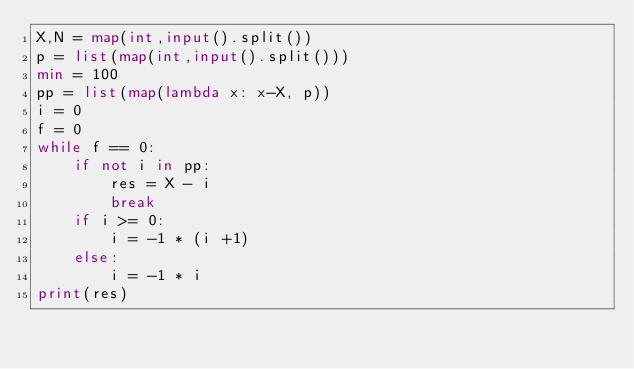Convert code to text. <code><loc_0><loc_0><loc_500><loc_500><_Python_>X,N = map(int,input().split())
p = list(map(int,input().split()))
min = 100
pp = list(map(lambda x: x-X, p))
i = 0
f = 0
while f == 0:
    if not i in pp:
        res = X - i
        break
    if i >= 0:
        i = -1 * (i +1)
    else:
        i = -1 * i
print(res)


</code> 